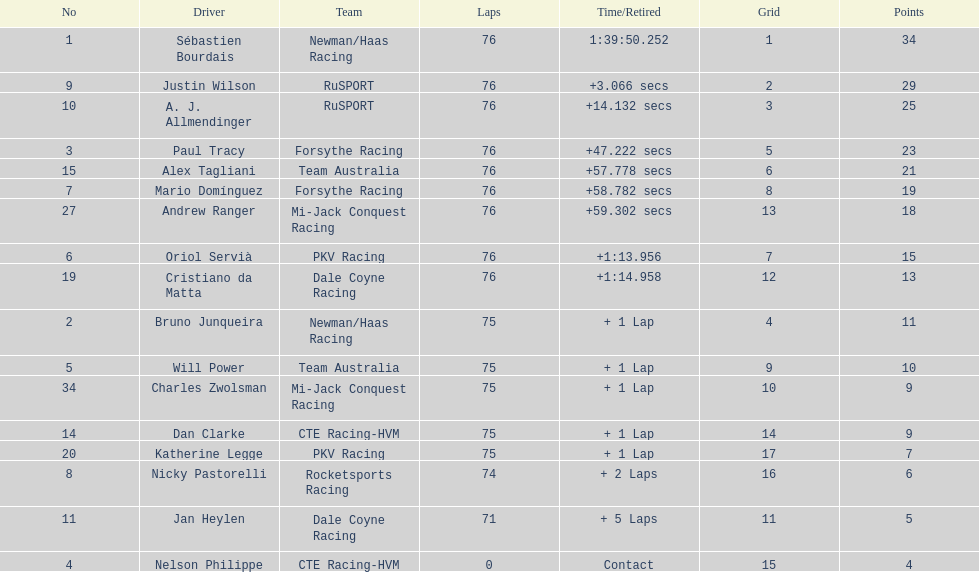What driver earned the most points? Sebastien Bourdais. 